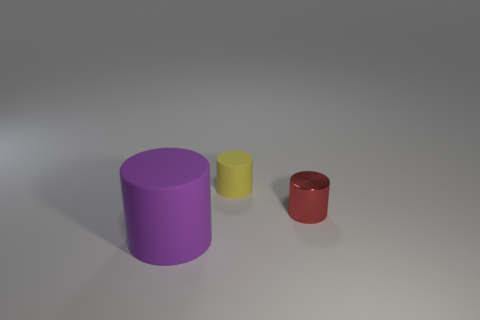There is a tiny thing in front of the tiny matte cylinder; are there any small cylinders on the left side of it?
Make the answer very short. Yes. What material is the thing that is the same size as the yellow rubber cylinder?
Give a very brief answer. Metal. Is there a metallic cube of the same size as the yellow matte cylinder?
Your response must be concise. No. There is a cylinder that is right of the small matte thing; what is its material?
Provide a short and direct response. Metal. Is the object in front of the red metal cylinder made of the same material as the yellow object?
Your answer should be compact. Yes. Are there fewer purple rubber cylinders in front of the big purple rubber object than things on the left side of the tiny red cylinder?
Your answer should be very brief. Yes. There is a purple matte thing; are there any tiny red shiny cylinders behind it?
Your answer should be compact. Yes. Is there a tiny red shiny cylinder that is to the left of the matte cylinder behind the rubber object that is in front of the yellow matte cylinder?
Your answer should be compact. No. There is a cylinder that is made of the same material as the yellow thing; what is its color?
Make the answer very short. Purple. What number of red things have the same material as the purple object?
Keep it short and to the point. 0. 